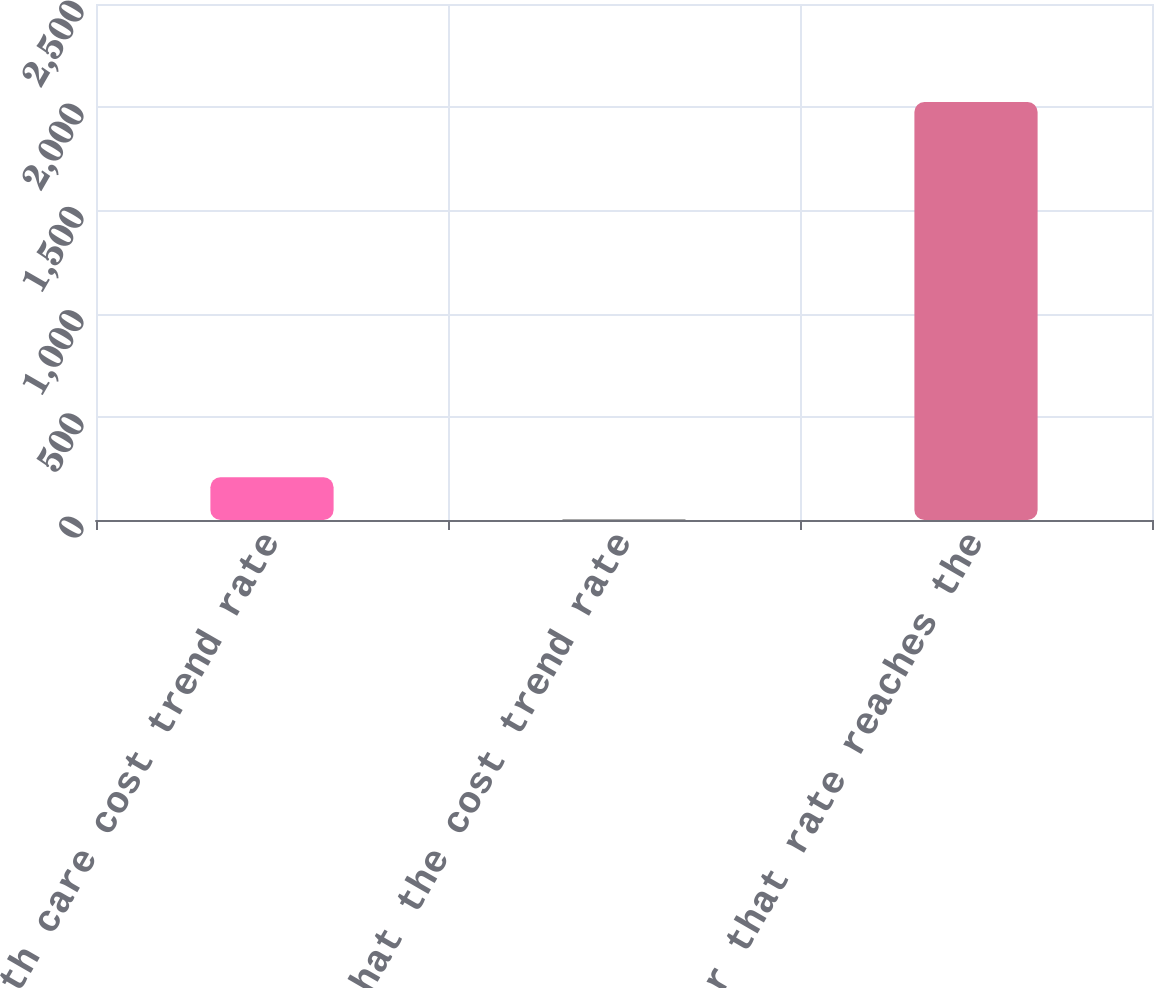Convert chart. <chart><loc_0><loc_0><loc_500><loc_500><bar_chart><fcel>Health care cost trend rate<fcel>Rate that the cost trend rate<fcel>Year that rate reaches the<nl><fcel>207<fcel>5<fcel>2025<nl></chart> 